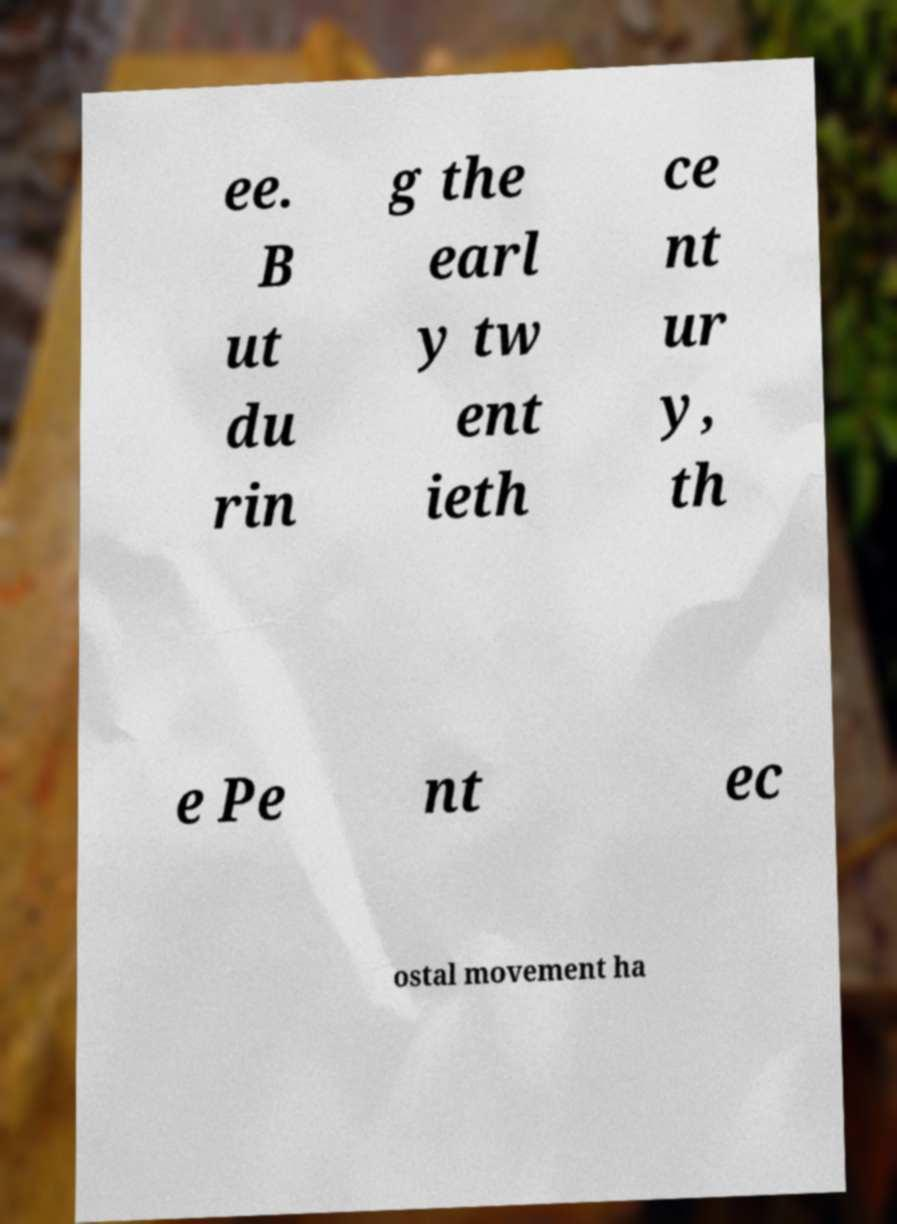Could you assist in decoding the text presented in this image and type it out clearly? ee. B ut du rin g the earl y tw ent ieth ce nt ur y, th e Pe nt ec ostal movement ha 